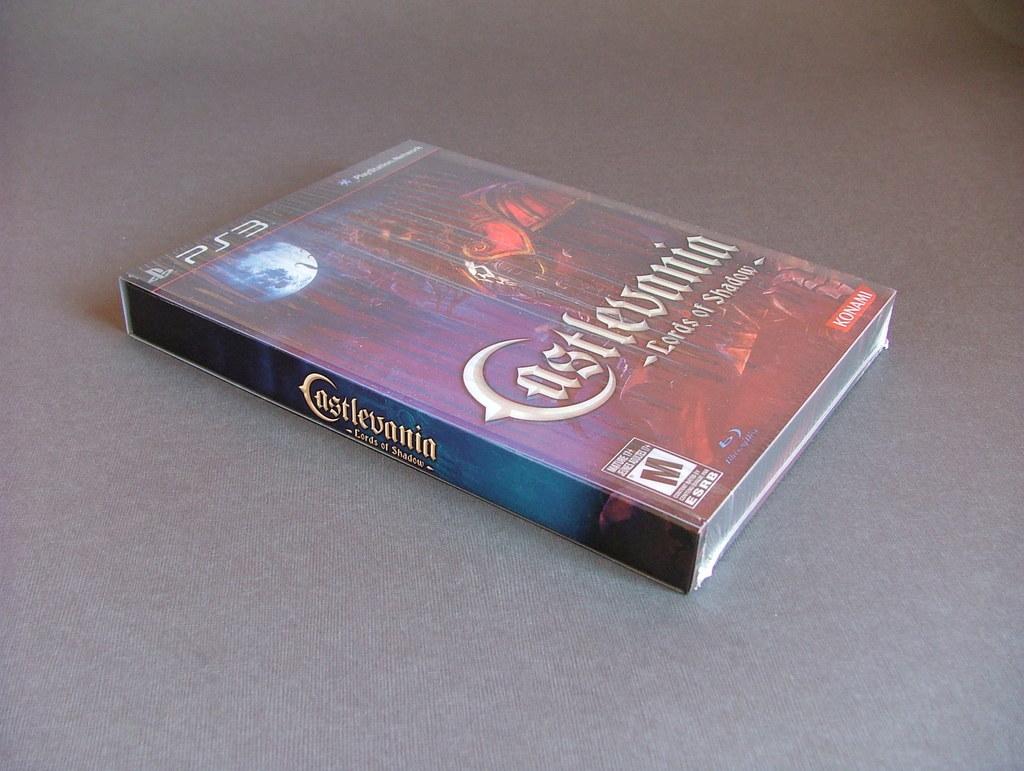What is the title of the game?
Offer a very short reply. Castlevania. 